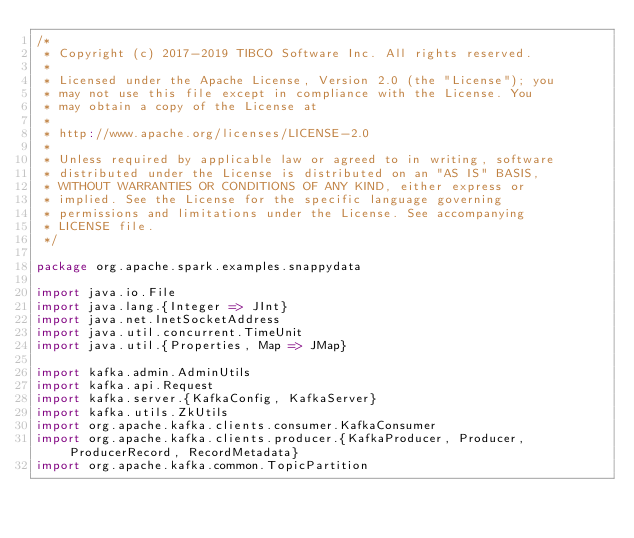Convert code to text. <code><loc_0><loc_0><loc_500><loc_500><_Scala_>/*
 * Copyright (c) 2017-2019 TIBCO Software Inc. All rights reserved.
 *
 * Licensed under the Apache License, Version 2.0 (the "License"); you
 * may not use this file except in compliance with the License. You
 * may obtain a copy of the License at
 *
 * http://www.apache.org/licenses/LICENSE-2.0
 *
 * Unless required by applicable law or agreed to in writing, software
 * distributed under the License is distributed on an "AS IS" BASIS,
 * WITHOUT WARRANTIES OR CONDITIONS OF ANY KIND, either express or
 * implied. See the License for the specific language governing
 * permissions and limitations under the License. See accompanying
 * LICENSE file.
 */

package org.apache.spark.examples.snappydata

import java.io.File
import java.lang.{Integer => JInt}
import java.net.InetSocketAddress
import java.util.concurrent.TimeUnit
import java.util.{Properties, Map => JMap}

import kafka.admin.AdminUtils
import kafka.api.Request
import kafka.server.{KafkaConfig, KafkaServer}
import kafka.utils.ZkUtils
import org.apache.kafka.clients.consumer.KafkaConsumer
import org.apache.kafka.clients.producer.{KafkaProducer, Producer, ProducerRecord, RecordMetadata}
import org.apache.kafka.common.TopicPartition</code> 